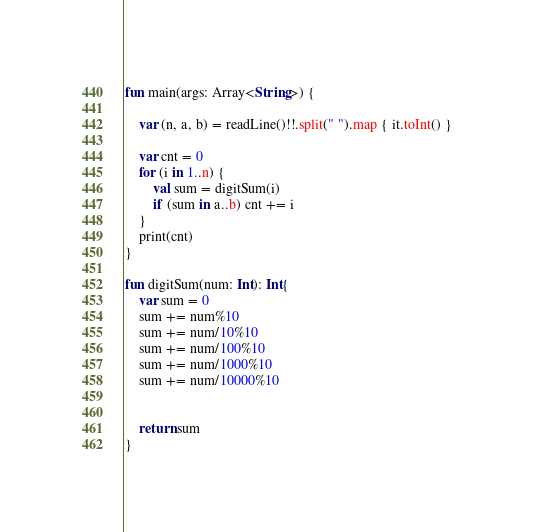Convert code to text. <code><loc_0><loc_0><loc_500><loc_500><_Kotlin_>fun main(args: Array<String>) {

    var (n, a, b) = readLine()!!.split(" ").map { it.toInt() }

    var cnt = 0
    for (i in 1..n) {
        val sum = digitSum(i)
        if (sum in a..b) cnt += i
    }
    print(cnt)
}

fun digitSum(num: Int): Int{
    var sum = 0
    sum += num%10
    sum += num/10%10
    sum += num/100%10
    sum += num/1000%10
    sum += num/10000%10


    return sum
}</code> 